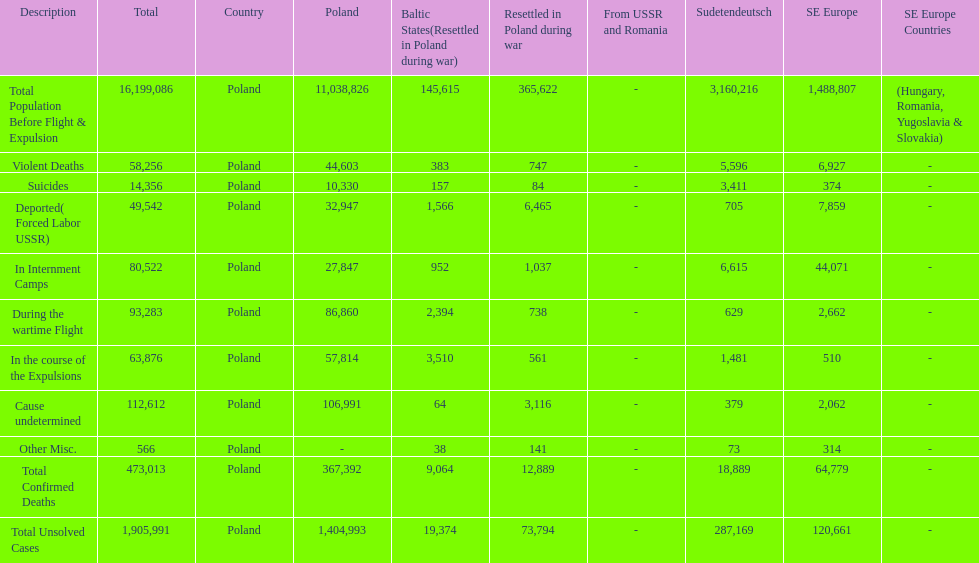What is the difference between suicides in poland and sudetendeutsch? 6919. 